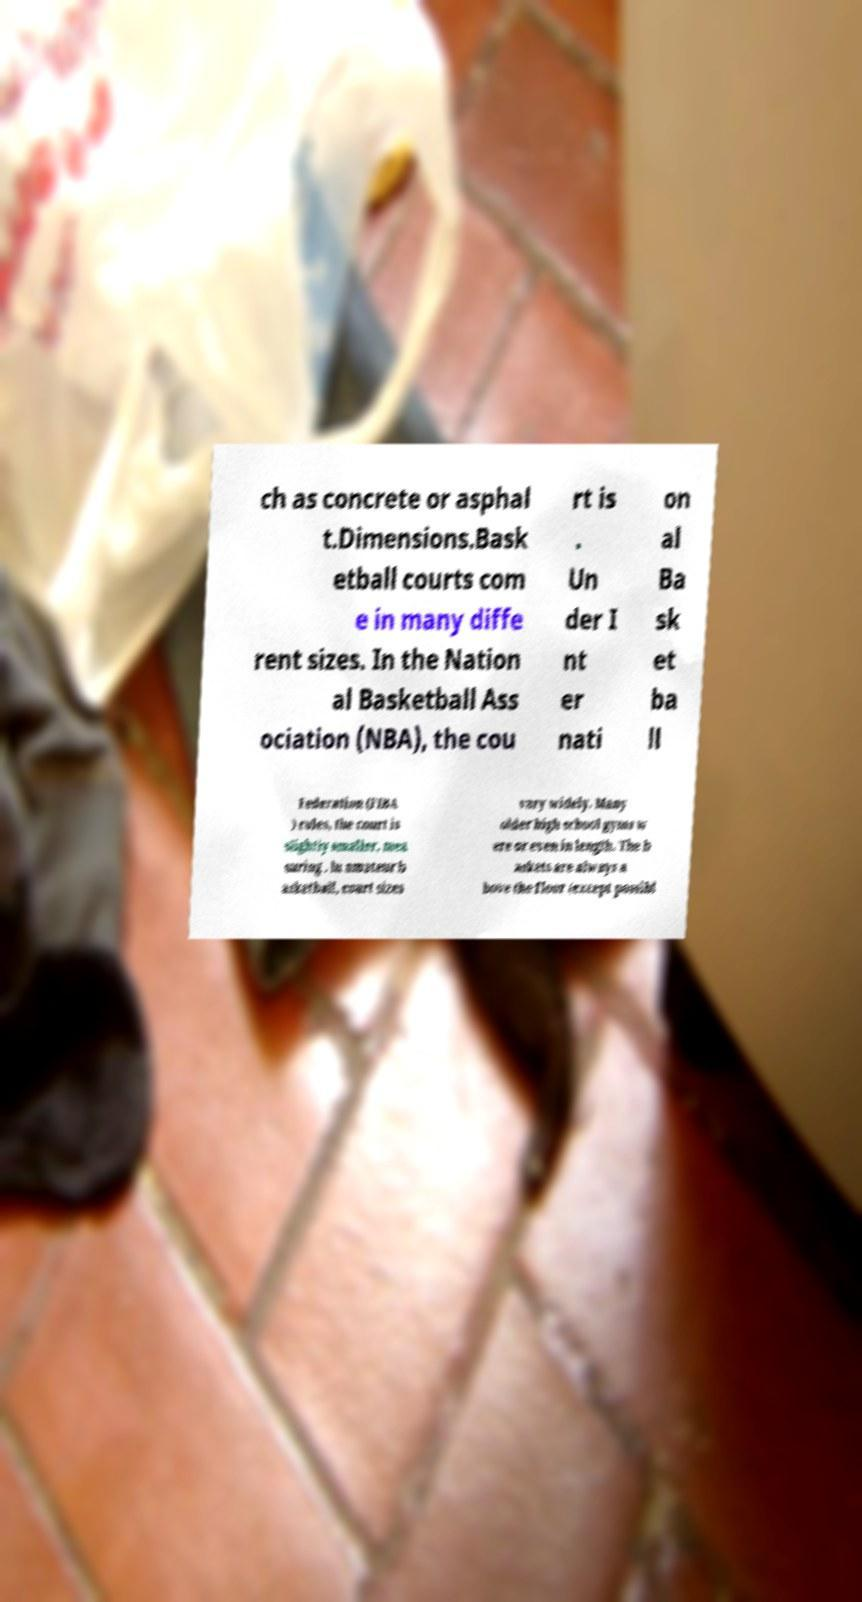Can you accurately transcribe the text from the provided image for me? ch as concrete or asphal t.Dimensions.Bask etball courts com e in many diffe rent sizes. In the Nation al Basketball Ass ociation (NBA), the cou rt is . Un der I nt er nati on al Ba sk et ba ll Federation (FIBA ) rules, the court is slightly smaller, mea suring . In amateur b asketball, court sizes vary widely. Many older high school gyms w ere or even in length. The b askets are always a bove the floor (except possibl 